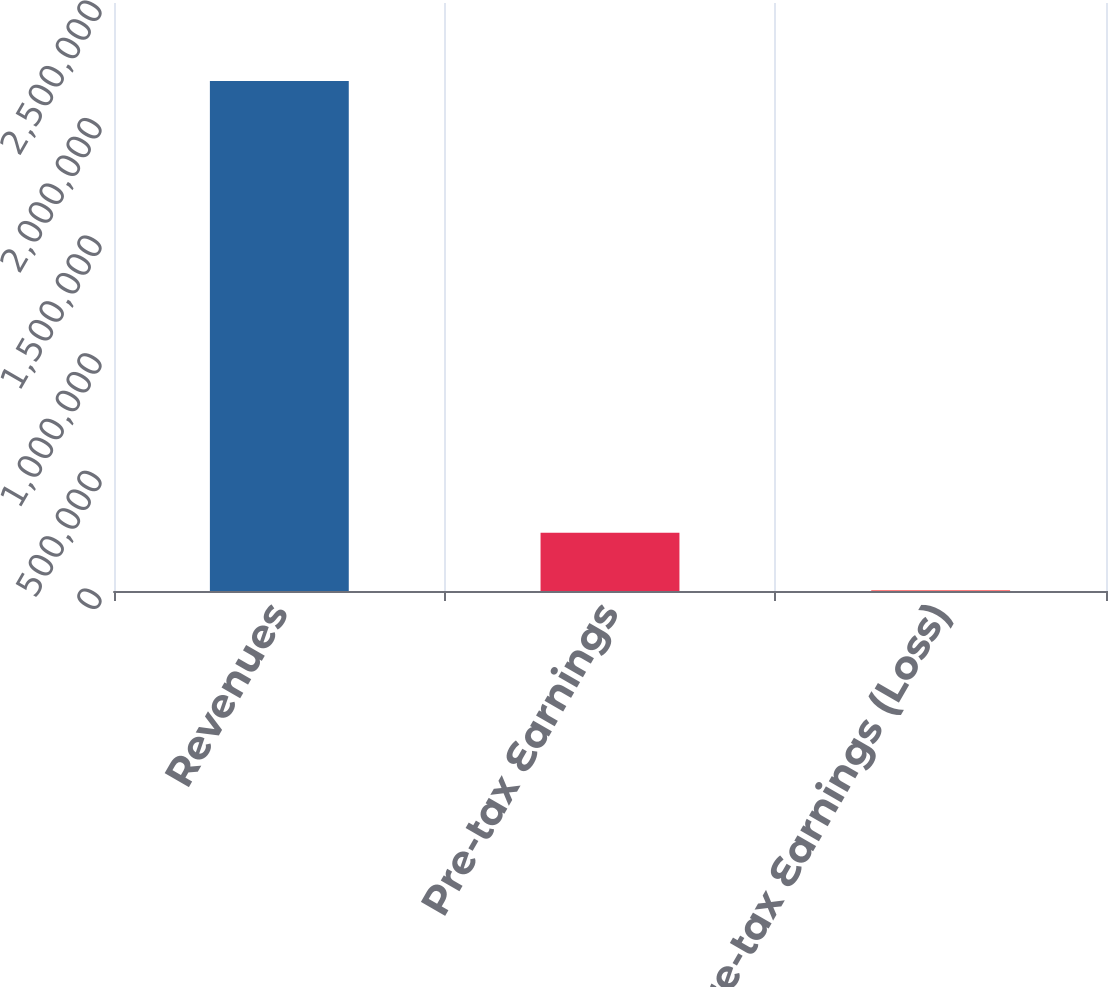Convert chart. <chart><loc_0><loc_0><loc_500><loc_500><bar_chart><fcel>Revenues<fcel>Pre-tax Earnings<fcel>Pre-tax Earnings (Loss)<nl><fcel>2.1682e+06<fcel>247971<fcel>2324<nl></chart> 